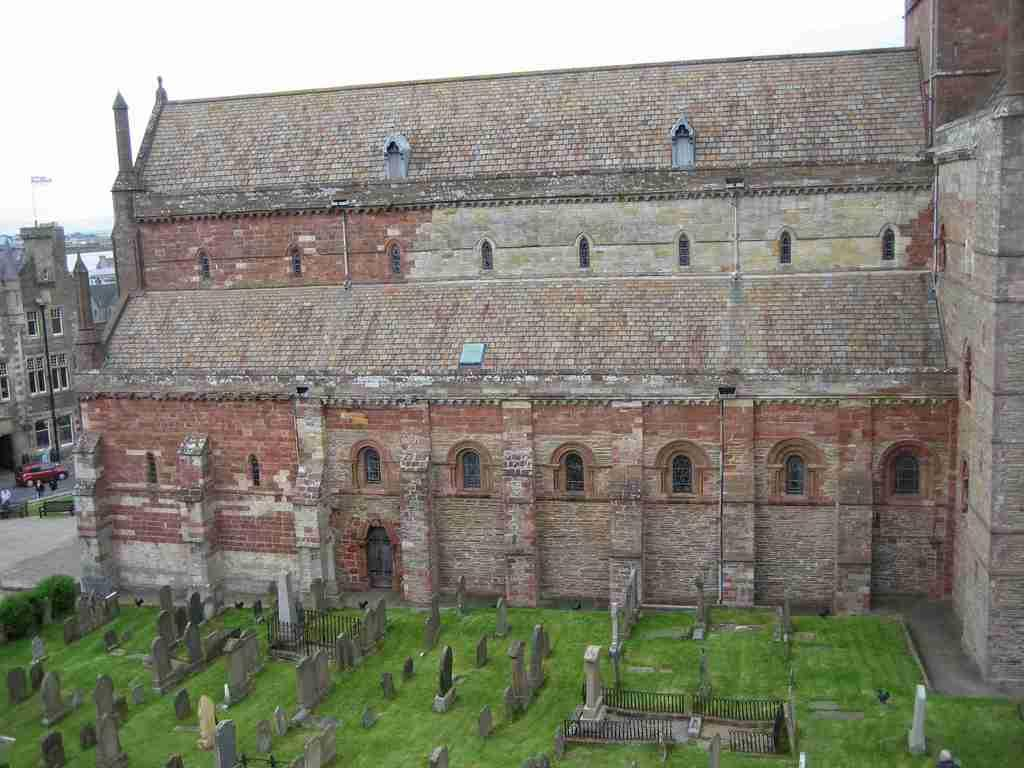What is the main structure in the center of the image? There is a building in the center of the image. What can be found at the bottom of the image? There is a graveyard at the bottom of the image. What type of vegetation is visible in the image? There is grass visible in the image. What type of impulse can be seen affecting the structure in the image? There is no impulse affecting the structure in the image; it is a static building. 